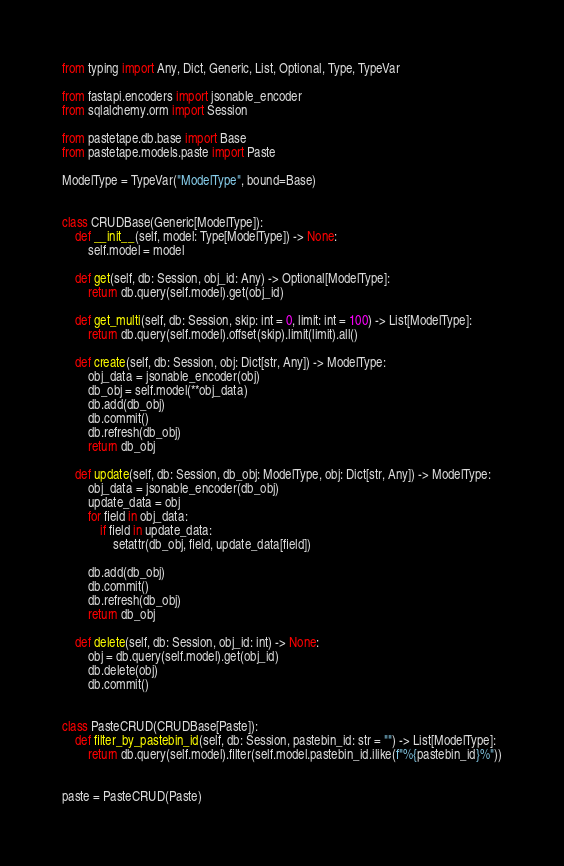Convert code to text. <code><loc_0><loc_0><loc_500><loc_500><_Python_>from typing import Any, Dict, Generic, List, Optional, Type, TypeVar

from fastapi.encoders import jsonable_encoder
from sqlalchemy.orm import Session

from pastetape.db.base import Base
from pastetape.models.paste import Paste

ModelType = TypeVar("ModelType", bound=Base)


class CRUDBase(Generic[ModelType]):
    def __init__(self, model: Type[ModelType]) -> None:
        self.model = model

    def get(self, db: Session, obj_id: Any) -> Optional[ModelType]:
        return db.query(self.model).get(obj_id)

    def get_multi(self, db: Session, skip: int = 0, limit: int = 100) -> List[ModelType]:
        return db.query(self.model).offset(skip).limit(limit).all()

    def create(self, db: Session, obj: Dict[str, Any]) -> ModelType:
        obj_data = jsonable_encoder(obj)
        db_obj = self.model(**obj_data)
        db.add(db_obj)
        db.commit()
        db.refresh(db_obj)
        return db_obj

    def update(self, db: Session, db_obj: ModelType, obj: Dict[str, Any]) -> ModelType:
        obj_data = jsonable_encoder(db_obj)
        update_data = obj
        for field in obj_data:
            if field in update_data:
                setattr(db_obj, field, update_data[field])

        db.add(db_obj)
        db.commit()
        db.refresh(db_obj)
        return db_obj

    def delete(self, db: Session, obj_id: int) -> None:
        obj = db.query(self.model).get(obj_id)
        db.delete(obj)
        db.commit()


class PasteCRUD(CRUDBase[Paste]):
    def filter_by_pastebin_id(self, db: Session, pastebin_id: str = "") -> List[ModelType]:
        return db.query(self.model).filter(self.model.pastebin_id.ilike(f"%{pastebin_id}%"))


paste = PasteCRUD(Paste)
</code> 